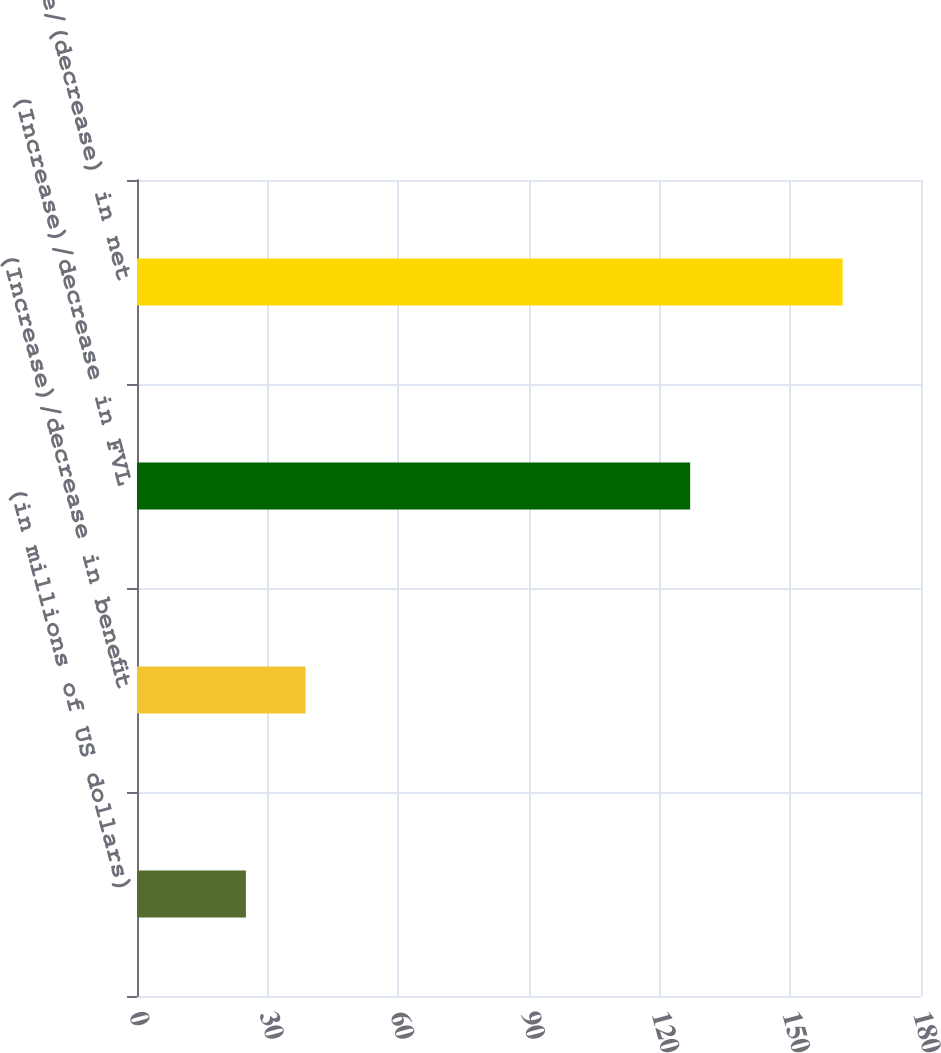Convert chart to OTSL. <chart><loc_0><loc_0><loc_500><loc_500><bar_chart><fcel>(in millions of US dollars)<fcel>(Increase)/decrease in benefit<fcel>(Increase)/decrease in FVL<fcel>Increase/(decrease) in net<nl><fcel>25<fcel>38.7<fcel>127<fcel>162<nl></chart> 